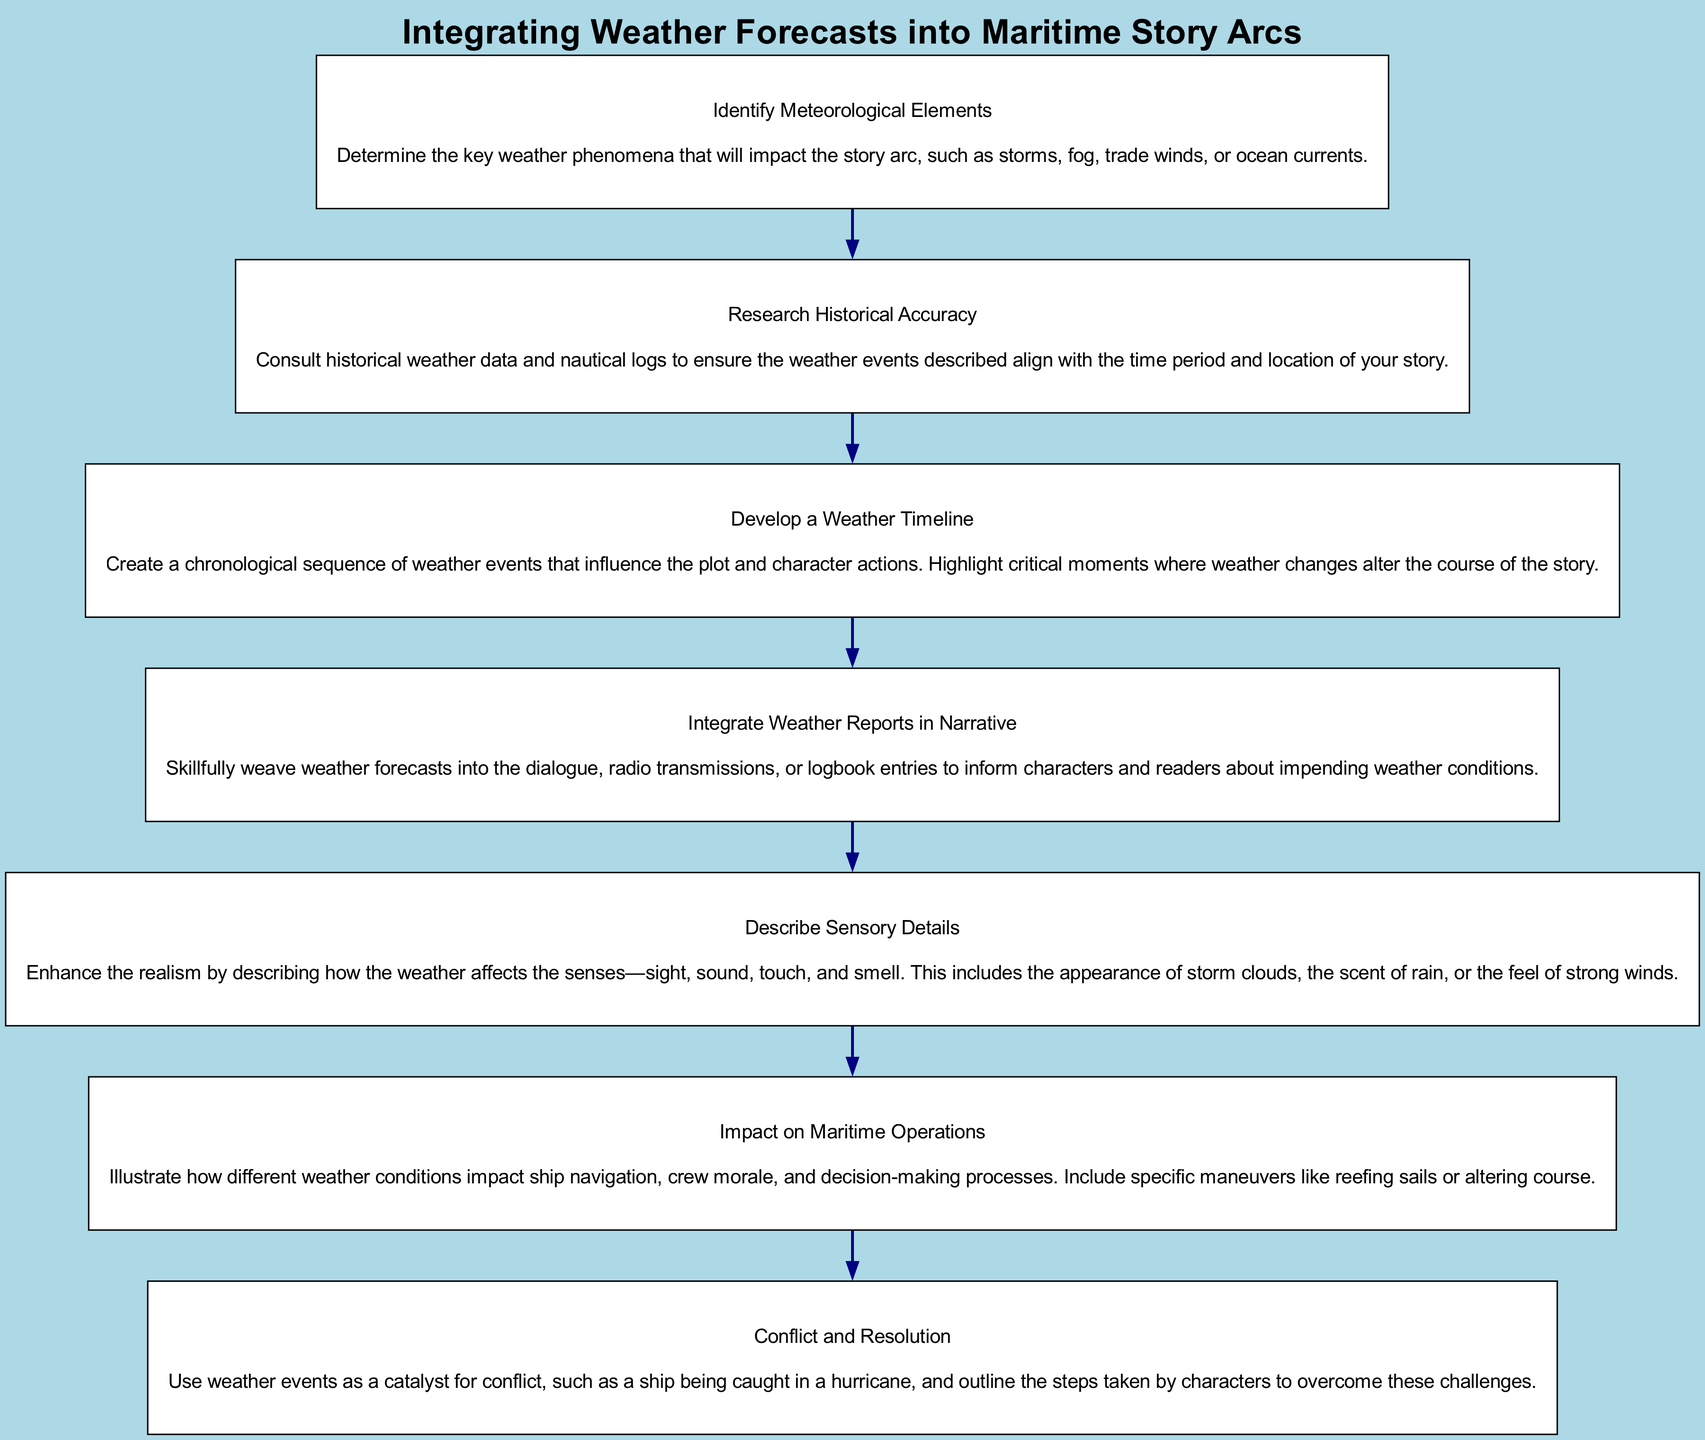What is the first step in the diagram? The first step is "Identify Meteorological Elements." This is evident as it is the topmost node in the flowchart and starts the sequence of instructions.
Answer: Identify Meteorological Elements How many total steps are there in the diagram? By counting the nodes, we see there are seven steps included in the flowchart.
Answer: 7 What follows after "Research Historical Accuracy"? The next step after "Research Historical Accuracy" is "Develop a Weather Timeline." To find this, we see that there is a directed edge leading from the second step to the third step in the sequence.
Answer: Develop a Weather Timeline Which step describes the impact of weather on ship navigation? The step describing this is "Impact on Maritime Operations." This can be determined by looking for the node that specifically mentions "ship navigation."
Answer: Impact on Maritime Operations How is conflict introduced in the story according to the diagram? "Conflict and Resolution" introduces conflict by using weather events, specifically mentioning scenarios like being caught in a hurricane as catalysts. This is clear from the description provided in that step.
Answer: Use weather events as a catalyst for conflict What are the sensory details included in the weather descriptions? "Describe Sensory Details" covers how weather affects the senses such as sight, sound, touch, and smell. This is specified in the description of that step.
Answer: Sight, sound, touch, and smell What step emphasizes incorporating weather information into characters' communication? The step "Integrate Weather Reports in Narrative" emphasizes this incorporation by suggesting weaving weather updates into dialogue or other forms of communication within the story.
Answer: Integrate Weather Reports in Narrative 